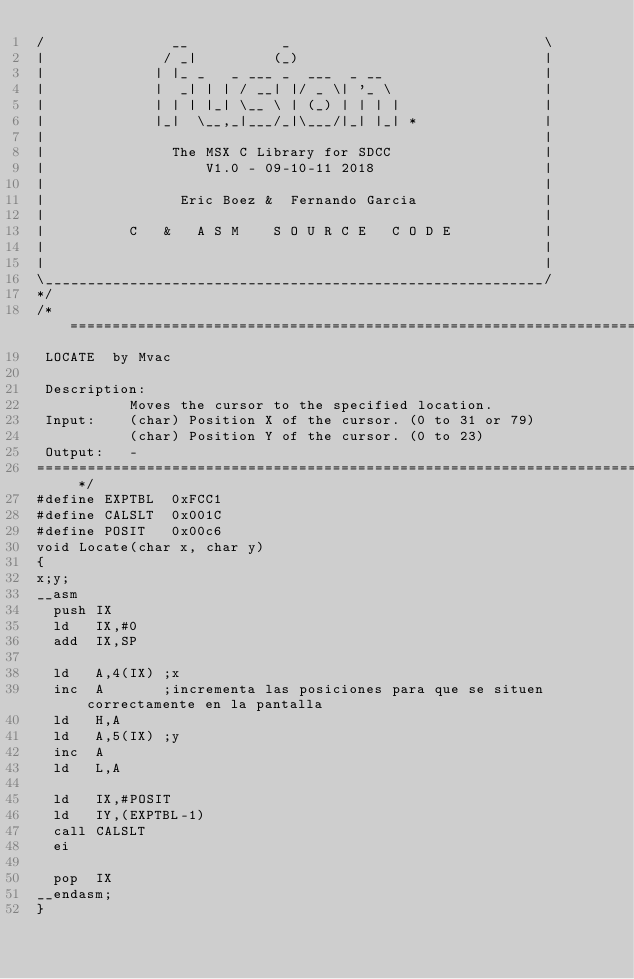<code> <loc_0><loc_0><loc_500><loc_500><_C_>/               __           _                              \
|              / _|         (_)                             |
|             | |_ _   _ ___ _  ___  _ __                   |
|             |  _| | | / __| |/ _ \| '_ \                  |
|             | | | |_| \__ \ | (_) | | | |                 |
|             |_|  \__,_|___/_|\___/|_| |_| *               |
|                                                           |
|               The MSX C Library for SDCC                  |
|                   V1.0 - 09-10-11 2018                    |
|                                                           |
|                Eric Boez &  Fernando Garcia               |
|                                                           |
|          C   &   A S M    S O U R C E   C O D E           |
|                                                           |
|                                                           |
\___________________________________________________________/
*/
/* =============================================================================
 LOCATE  by Mvac
 
 Description: 
           Moves the cursor to the specified location.
 Input:    (char) Position X of the cursor. (0 to 31 or 79)
           (char) Position Y of the cursor. (0 to 23)         
 Output:   -
============================================================================= */
#define EXPTBL  0xFCC1
#define CALSLT  0x001C
#define POSIT   0x00c6
void Locate(char x, char y)
{
x;y;
__asm
  push IX
  ld   IX,#0
  add  IX,SP
  
  ld   A,4(IX) ;x
  inc  A       ;incrementa las posiciones para que se situen correctamente en la pantalla
  ld   H,A
  ld   A,5(IX) ;y
  inc  A
  ld   L,A
     
  ld   IX,#POSIT
  ld   IY,(EXPTBL-1)
  call CALSLT
  ei
  
  pop  IX
__endasm;
}</code> 